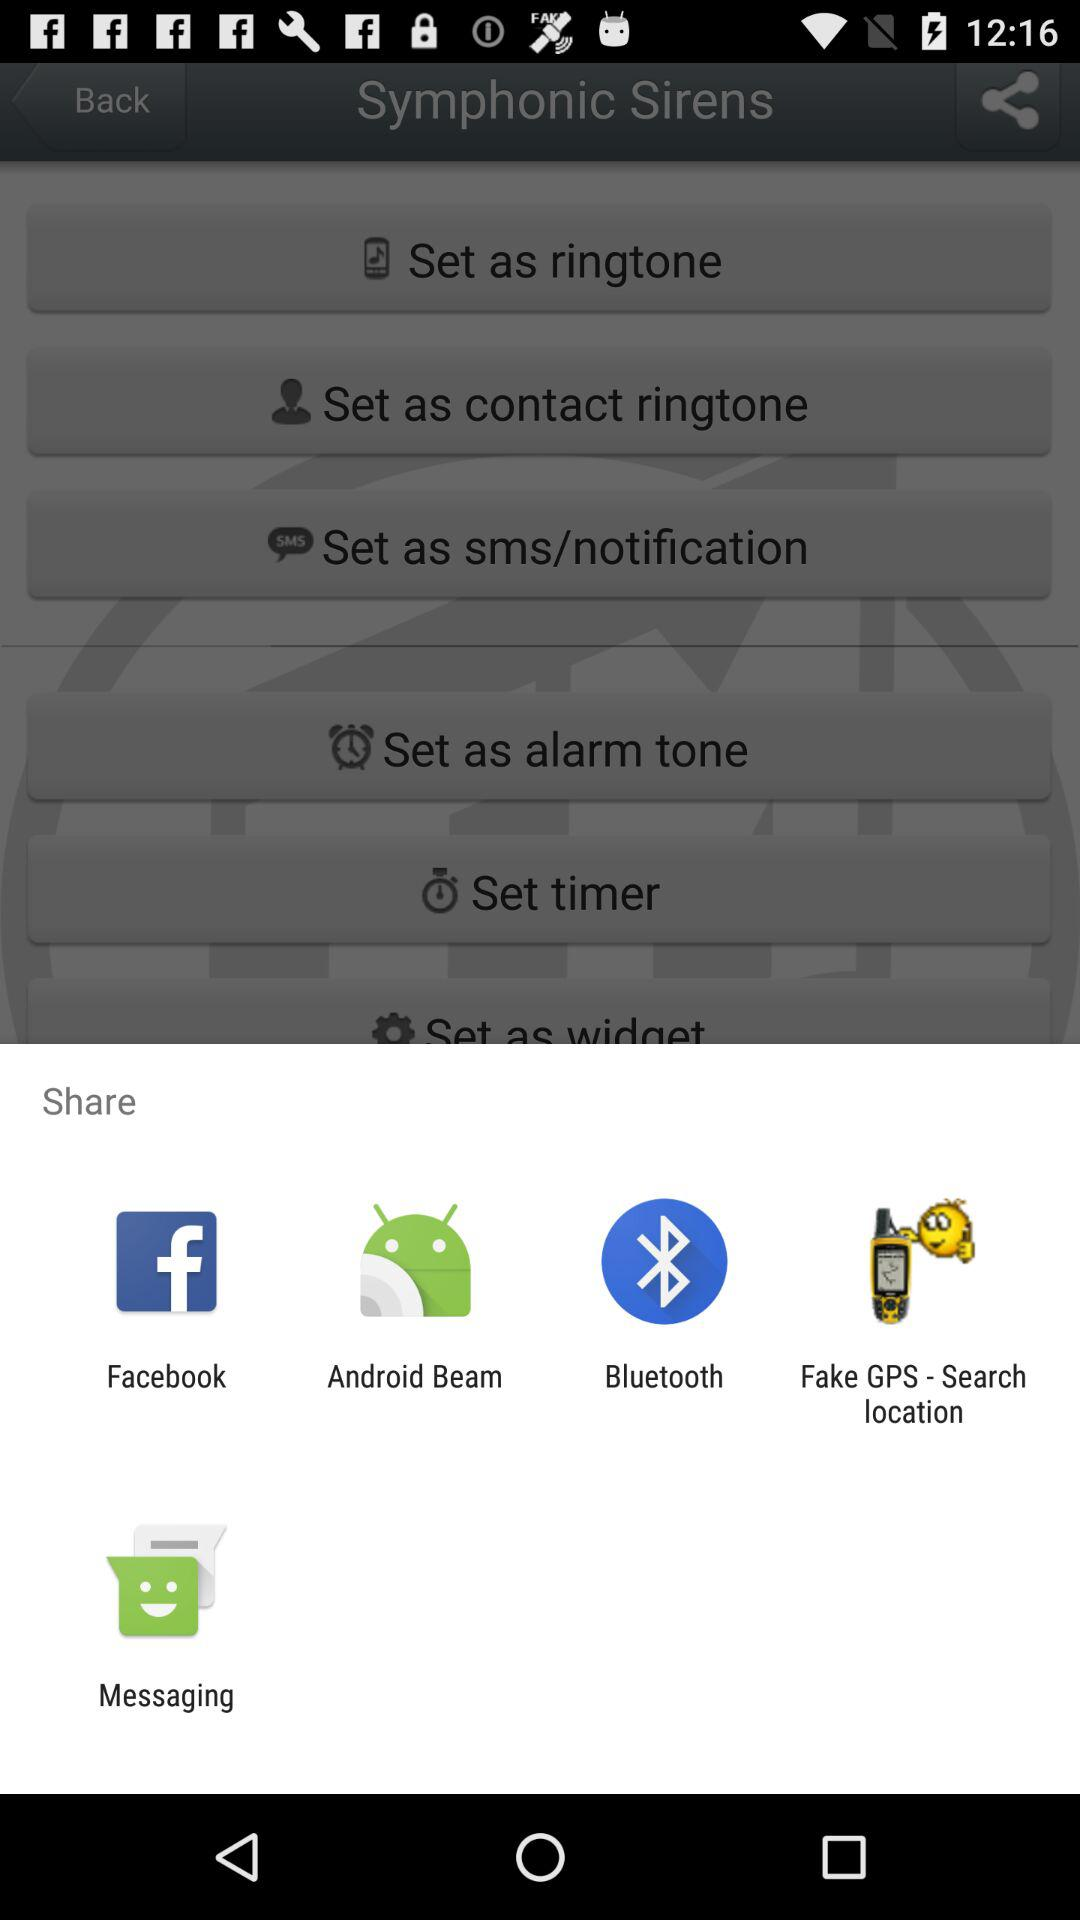What application can I use to share? You can use "Facebook", "Android Beam", "Bluetooth", "Fake GPS - Search location" and "Messaging" to share. 